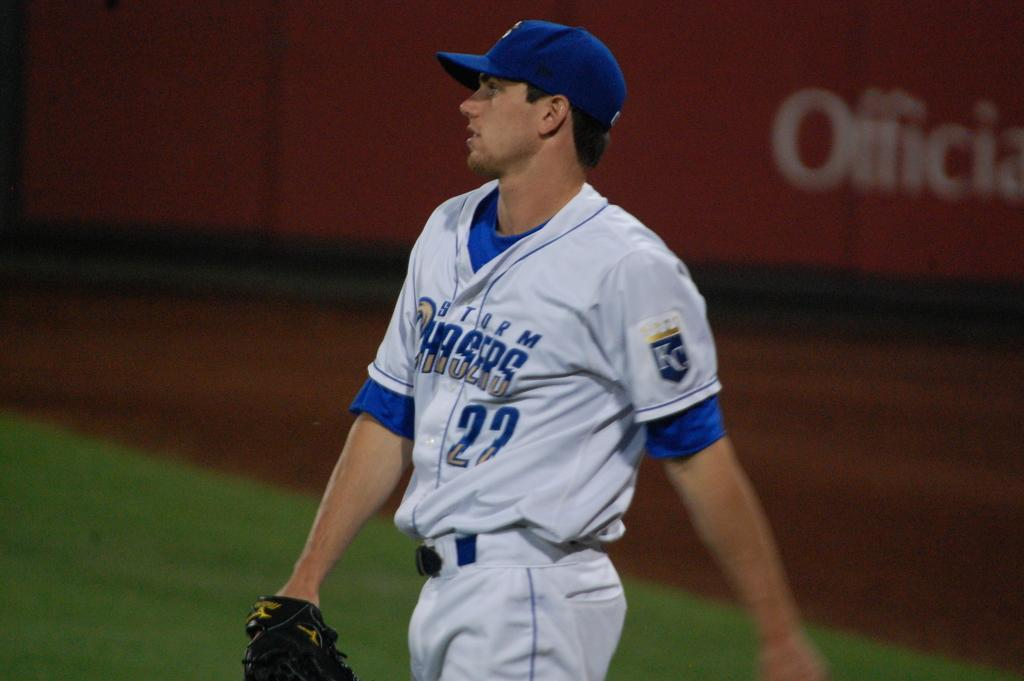<image>
Share a concise interpretation of the image provided. A man in a  blue and white top which has the word Chasers on it. 